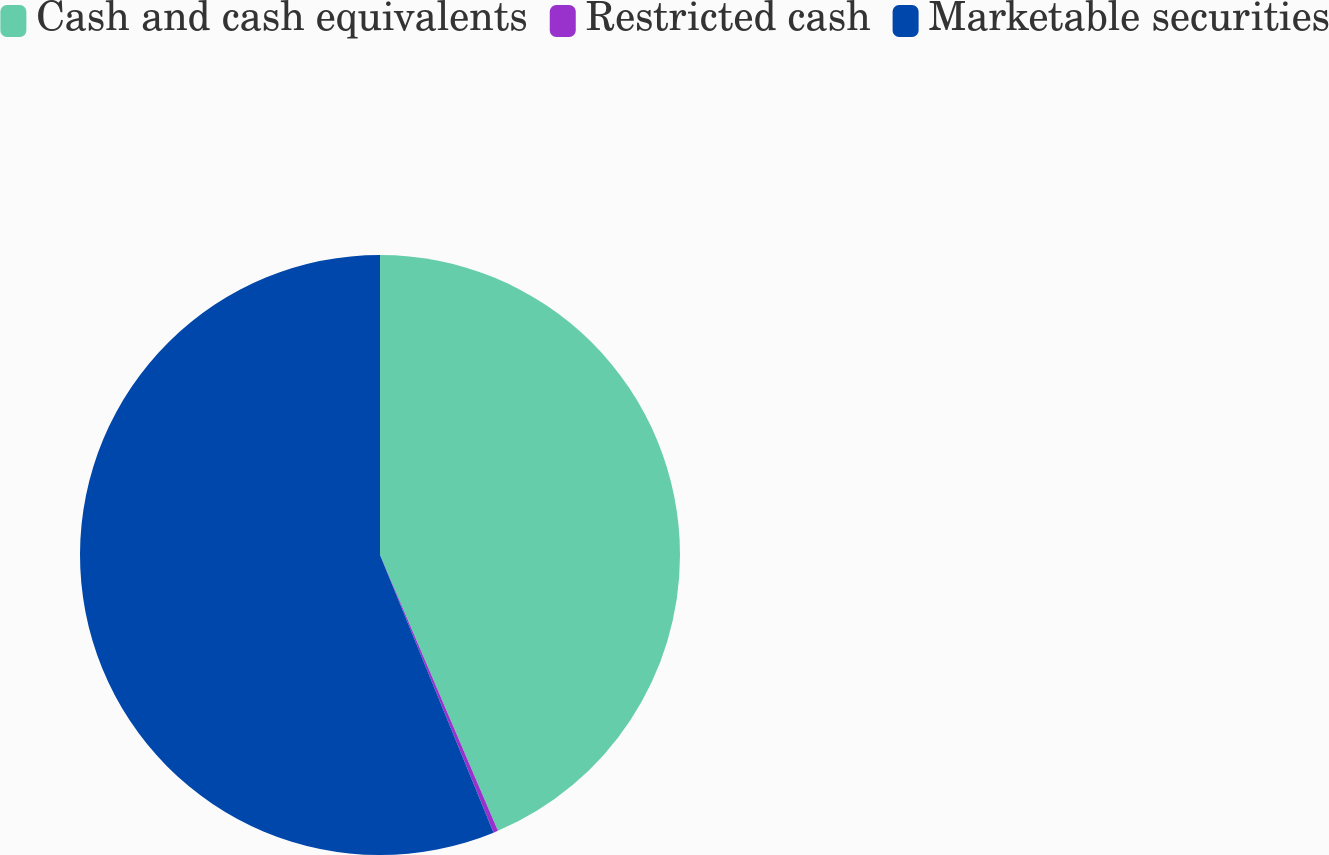<chart> <loc_0><loc_0><loc_500><loc_500><pie_chart><fcel>Cash and cash equivalents<fcel>Restricted cash<fcel>Marketable securities<nl><fcel>43.57%<fcel>0.25%<fcel>56.18%<nl></chart> 